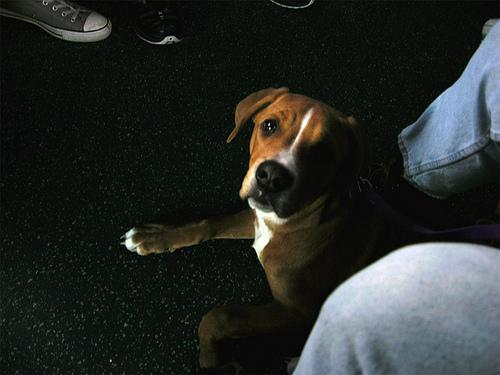What kind of animal is the primary focus in the image and what is its position? The main animal in the image is a brown and white dog lying on the concrete ground. What type of footwear is the person wearing and what are its main colors? The person is wearing grey tennis shoes with white laces. Briefly describe the appearance of the dog in the photograph. The dog is brown and white, with a black nose and black eyes, and has distinctive markings such as a white stripe on its head. Identify a clothing item worn by the human in the picture and its color. The person in the image is wearing blue jeans. Based on the image, what is the most likely context for a product advertisement using this visual? An advertisement for pet products, such as dog leashes or collars, or pet-friendly shoes. 